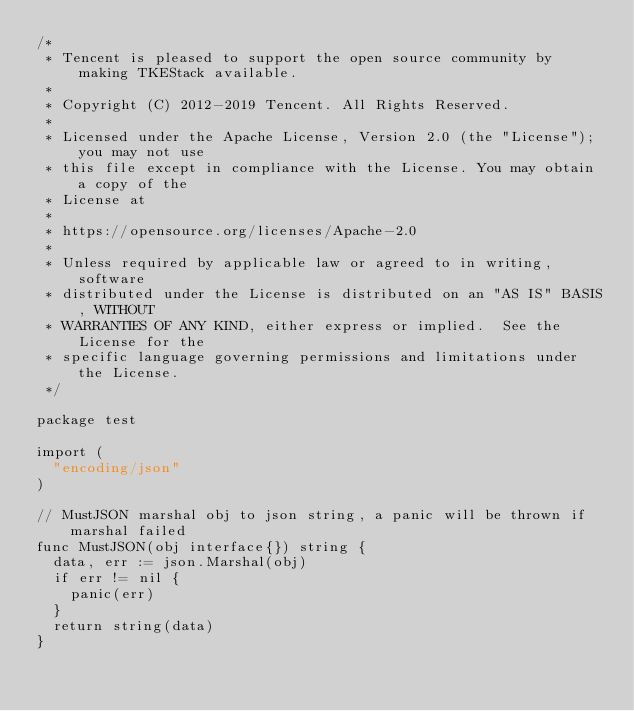Convert code to text. <code><loc_0><loc_0><loc_500><loc_500><_Go_>/*
 * Tencent is pleased to support the open source community by making TKEStack available.
 *
 * Copyright (C) 2012-2019 Tencent. All Rights Reserved.
 *
 * Licensed under the Apache License, Version 2.0 (the "License"); you may not use
 * this file except in compliance with the License. You may obtain a copy of the
 * License at
 *
 * https://opensource.org/licenses/Apache-2.0
 *
 * Unless required by applicable law or agreed to in writing, software
 * distributed under the License is distributed on an "AS IS" BASIS, WITHOUT
 * WARRANTIES OF ANY KIND, either express or implied.  See the License for the
 * specific language governing permissions and limitations under the License.
 */

package test

import (
	"encoding/json"
)

// MustJSON marshal obj to json string, a panic will be thrown if marshal failed
func MustJSON(obj interface{}) string {
	data, err := json.Marshal(obj)
	if err != nil {
		panic(err)
	}
	return string(data)
}
</code> 